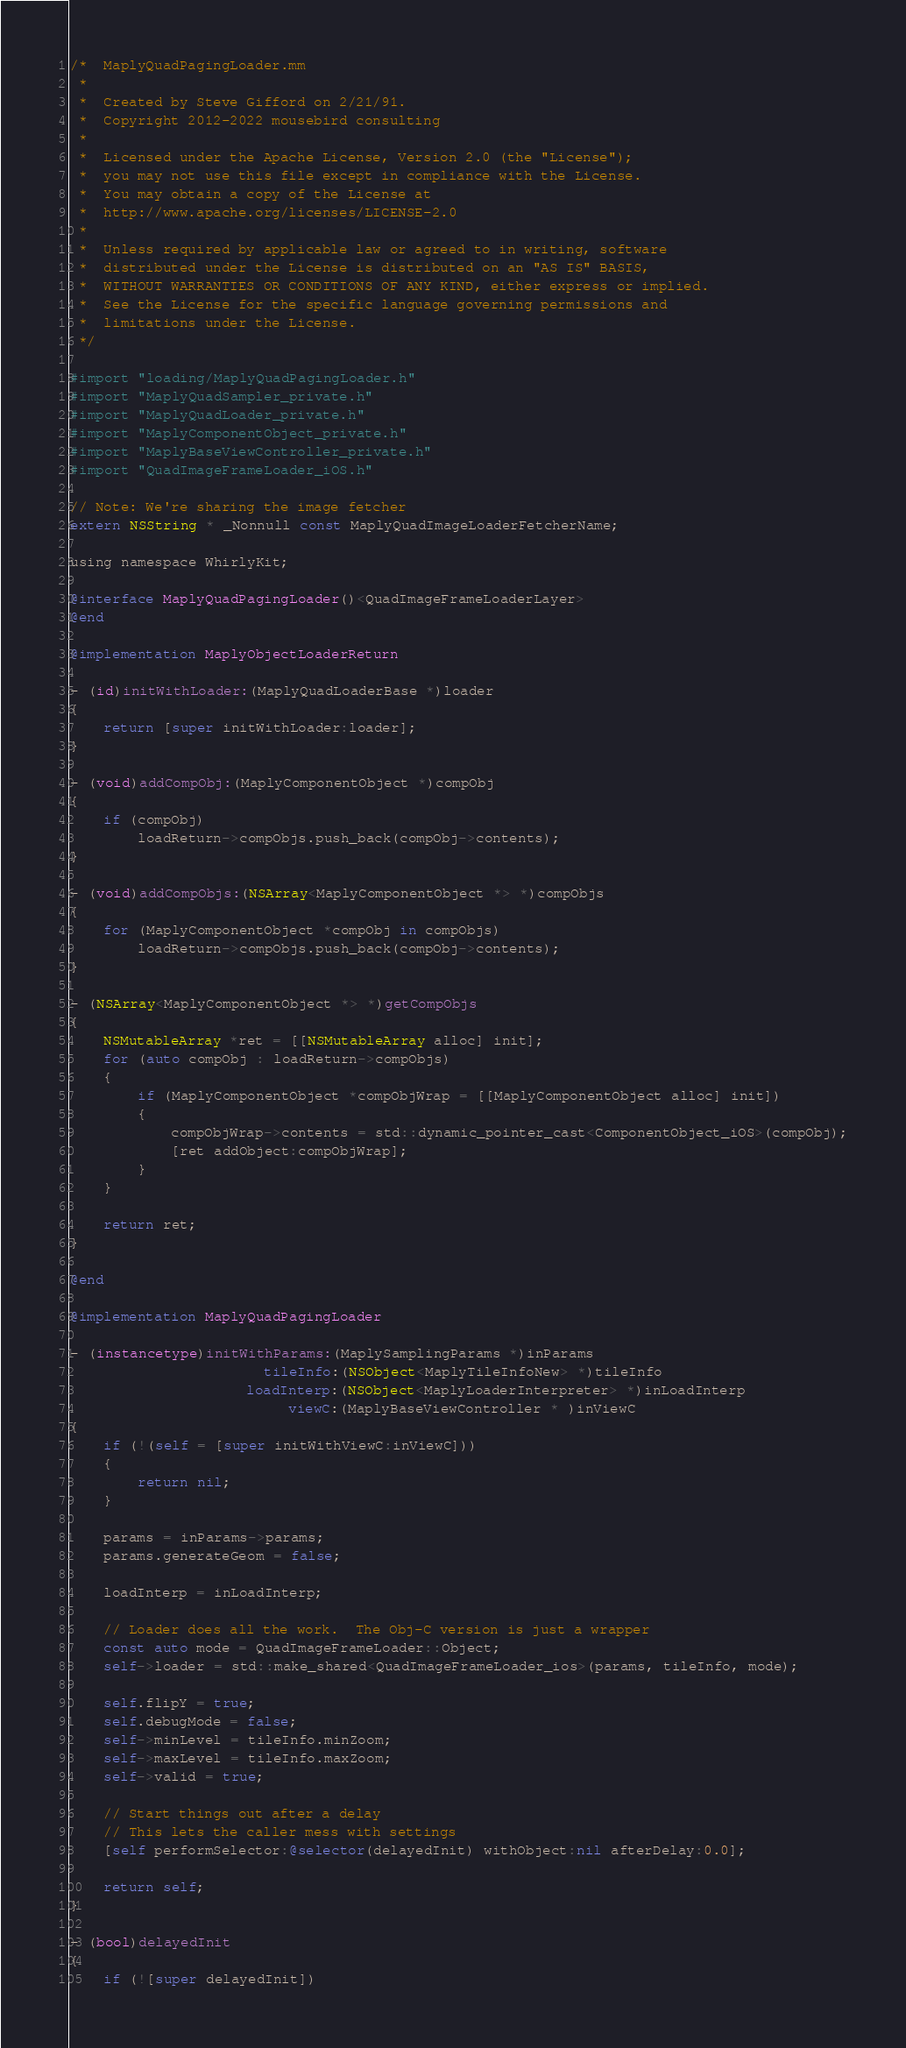<code> <loc_0><loc_0><loc_500><loc_500><_ObjectiveC_>/*  MaplyQuadPagingLoader.mm
 *
 *  Created by Steve Gifford on 2/21/91.
 *  Copyright 2012-2022 mousebird consulting
 *
 *  Licensed under the Apache License, Version 2.0 (the "License");
 *  you may not use this file except in compliance with the License.
 *  You may obtain a copy of the License at
 *  http://www.apache.org/licenses/LICENSE-2.0
 *
 *  Unless required by applicable law or agreed to in writing, software
 *  distributed under the License is distributed on an "AS IS" BASIS,
 *  WITHOUT WARRANTIES OR CONDITIONS OF ANY KIND, either express or implied.
 *  See the License for the specific language governing permissions and
 *  limitations under the License.
 */

#import "loading/MaplyQuadPagingLoader.h"
#import "MaplyQuadSampler_private.h"
#import "MaplyQuadLoader_private.h"
#import "MaplyComponentObject_private.h"
#import "MaplyBaseViewController_private.h"
#import "QuadImageFrameLoader_iOS.h"

// Note: We're sharing the image fetcher
extern NSString * _Nonnull const MaplyQuadImageLoaderFetcherName;

using namespace WhirlyKit;

@interface MaplyQuadPagingLoader()<QuadImageFrameLoaderLayer>
@end

@implementation MaplyObjectLoaderReturn

- (id)initWithLoader:(MaplyQuadLoaderBase *)loader
{
    return [super initWithLoader:loader];
}

- (void)addCompObj:(MaplyComponentObject *)compObj
{
    if (compObj)
        loadReturn->compObjs.push_back(compObj->contents);
}

- (void)addCompObjs:(NSArray<MaplyComponentObject *> *)compObjs
{
    for (MaplyComponentObject *compObj in compObjs)
        loadReturn->compObjs.push_back(compObj->contents);
}

- (NSArray<MaplyComponentObject *> *)getCompObjs
{
    NSMutableArray *ret = [[NSMutableArray alloc] init];
    for (auto compObj : loadReturn->compObjs)
    {
        if (MaplyComponentObject *compObjWrap = [[MaplyComponentObject alloc] init])
        {
            compObjWrap->contents = std::dynamic_pointer_cast<ComponentObject_iOS>(compObj);
            [ret addObject:compObjWrap];
        }
    }
    
    return ret;
}

@end

@implementation MaplyQuadPagingLoader

- (instancetype)initWithParams:(MaplySamplingParams *)inParams
                       tileInfo:(NSObject<MaplyTileInfoNew> *)tileInfo
                     loadInterp:(NSObject<MaplyLoaderInterpreter> *)inLoadInterp
                          viewC:(MaplyBaseViewController * )inViewC
{
    if (!(self = [super initWithViewC:inViewC]))
    {
        return nil;
    }

    params = inParams->params;
    params.generateGeom = false;
    
    loadInterp = inLoadInterp;

    // Loader does all the work.  The Obj-C version is just a wrapper
    const auto mode = QuadImageFrameLoader::Object;
    self->loader = std::make_shared<QuadImageFrameLoader_ios>(params, tileInfo, mode);

    self.flipY = true;
    self.debugMode = false;
    self->minLevel = tileInfo.minZoom;
    self->maxLevel = tileInfo.maxZoom;
    self->valid = true;

    // Start things out after a delay
    // This lets the caller mess with settings
    [self performSelector:@selector(delayedInit) withObject:nil afterDelay:0.0];
    
    return self;
}

- (bool)delayedInit
{
    if (![super delayedInit])</code> 